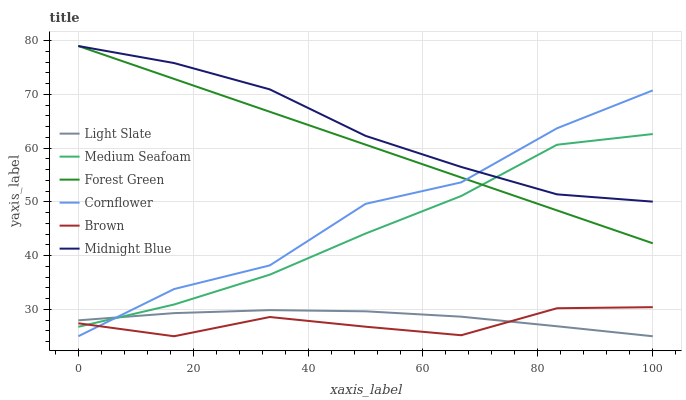Does Brown have the minimum area under the curve?
Answer yes or no. Yes. Does Midnight Blue have the maximum area under the curve?
Answer yes or no. Yes. Does Midnight Blue have the minimum area under the curve?
Answer yes or no. No. Does Brown have the maximum area under the curve?
Answer yes or no. No. Is Forest Green the smoothest?
Answer yes or no. Yes. Is Cornflower the roughest?
Answer yes or no. Yes. Is Midnight Blue the smoothest?
Answer yes or no. No. Is Midnight Blue the roughest?
Answer yes or no. No. Does Cornflower have the lowest value?
Answer yes or no. Yes. Does Midnight Blue have the lowest value?
Answer yes or no. No. Does Forest Green have the highest value?
Answer yes or no. Yes. Does Brown have the highest value?
Answer yes or no. No. Is Light Slate less than Forest Green?
Answer yes or no. Yes. Is Forest Green greater than Light Slate?
Answer yes or no. Yes. Does Brown intersect Light Slate?
Answer yes or no. Yes. Is Brown less than Light Slate?
Answer yes or no. No. Is Brown greater than Light Slate?
Answer yes or no. No. Does Light Slate intersect Forest Green?
Answer yes or no. No. 